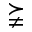<formula> <loc_0><loc_0><loc_500><loc_500>\succneqq</formula> 